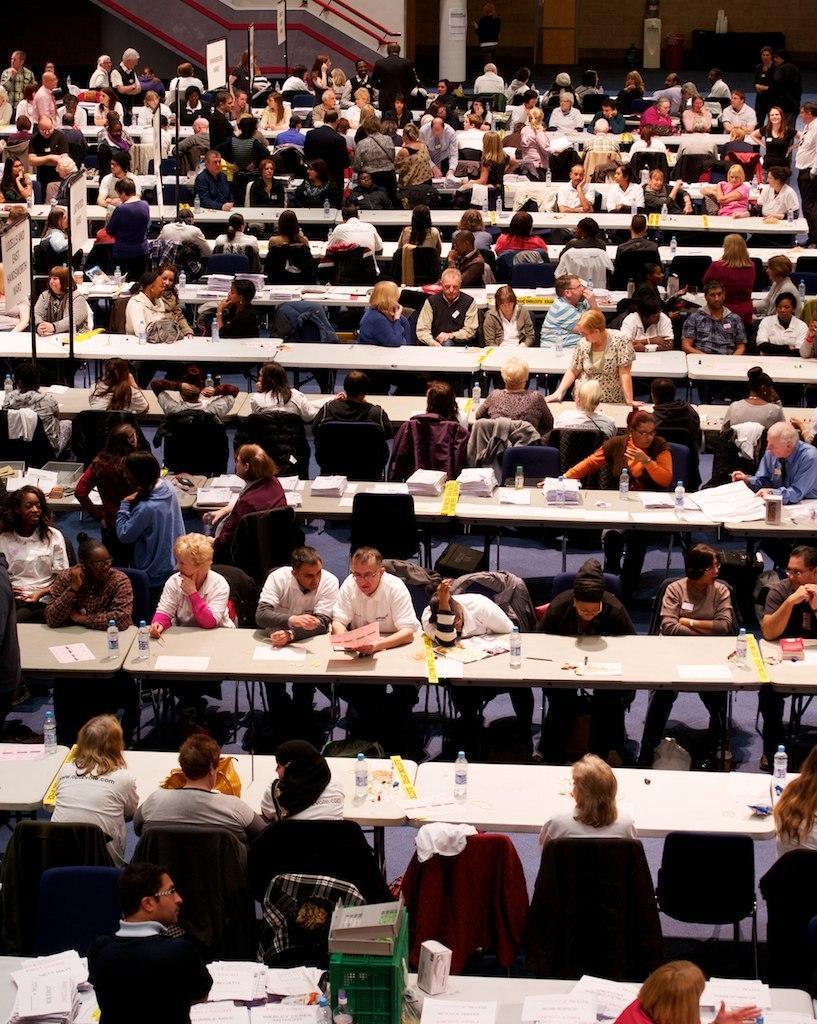Describe this image in one or two sentences. There are group of people sitting and few people standing. We can see boards on poles and we can see bottles, papers and objects on tables. In the background we can see poster on pillar, wall and few objects. 